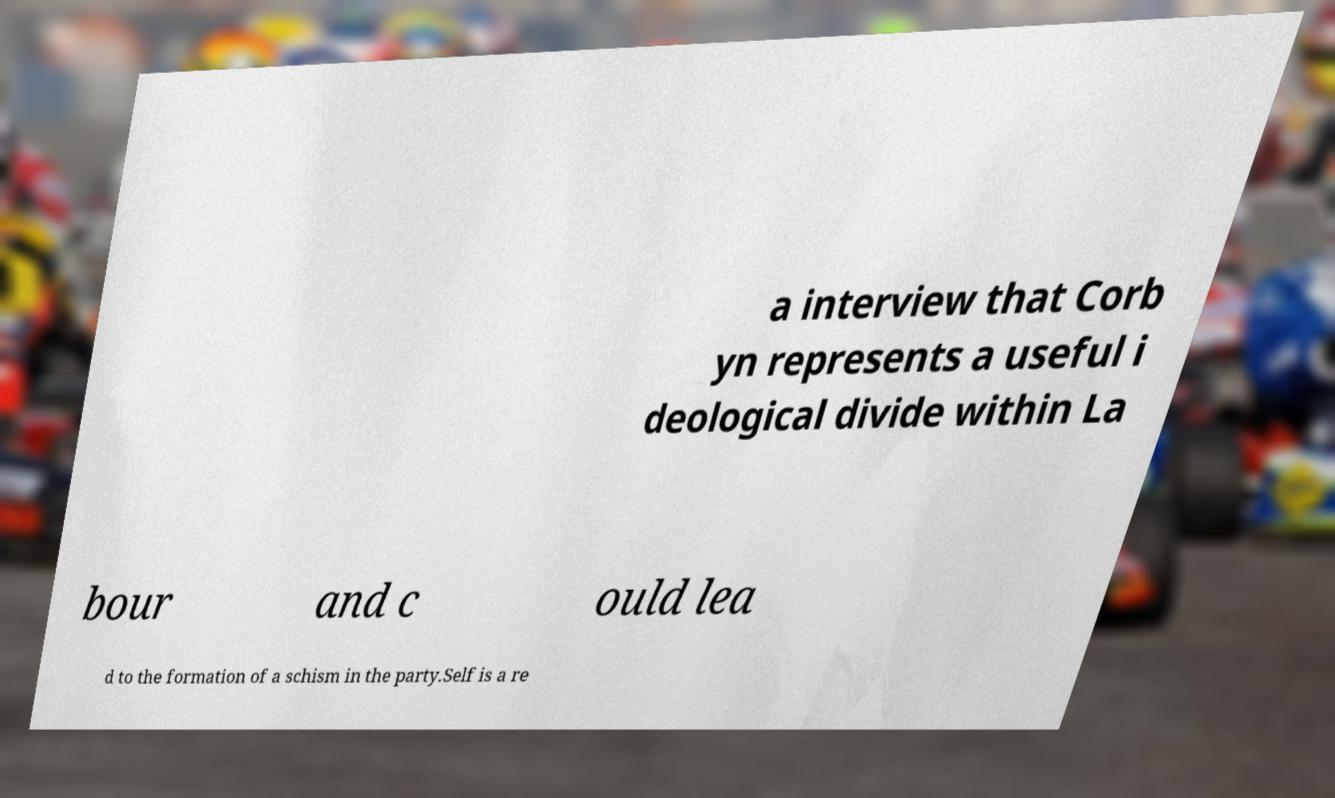Could you extract and type out the text from this image? a interview that Corb yn represents a useful i deological divide within La bour and c ould lea d to the formation of a schism in the party.Self is a re 